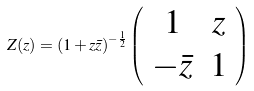<formula> <loc_0><loc_0><loc_500><loc_500>Z ( z ) = ( 1 + z \bar { z } ) ^ { - \frac { 1 } { 2 } } \left ( \begin{array} { c c } 1 & z \\ - \bar { z } & 1 \end{array} \right )</formula> 